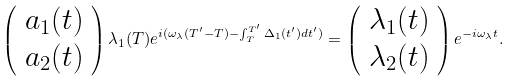<formula> <loc_0><loc_0><loc_500><loc_500>\left ( \begin{array} { l l } a _ { 1 } ( t ) \\ a _ { 2 } ( t ) \end{array} \right ) \lambda _ { 1 } ( T ) e ^ { i ( \omega _ { \lambda } ( T ^ { \prime } - T ) - \int _ { T } ^ { T ^ { \prime } } \Delta _ { 1 } ( t ^ { \prime } ) d t ^ { \prime } ) } = \left ( \begin{array} { l l } \lambda _ { 1 } ( t ) \\ \lambda _ { 2 } ( t ) \end{array} \right ) e ^ { - i \omega _ { \lambda } t } .</formula> 